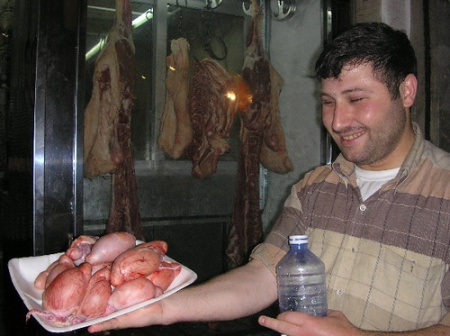How does the presentation of the meat reflect on the professional identity or pride of the individual shown? The man's joyful expression and the meticulous presentation of the meats on his plate and in the window display strongly reflect a sense of pride and professional identity. This pride likely stems from mastering the craft of butchery or the retail of high-quality meats. His casual yet neat attire and the deliberate placement of the meats to be visually appealing suggest that he is knowledgeable and passionate about his trade, aiming to attract and assure customers of the quality and care taken in his products. 